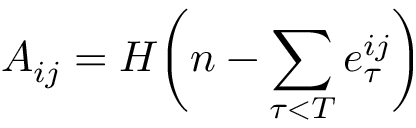Convert formula to latex. <formula><loc_0><loc_0><loc_500><loc_500>A _ { i j } = H \left ( n - \sum _ { \tau < T } e _ { \tau } ^ { i j } \right )</formula> 